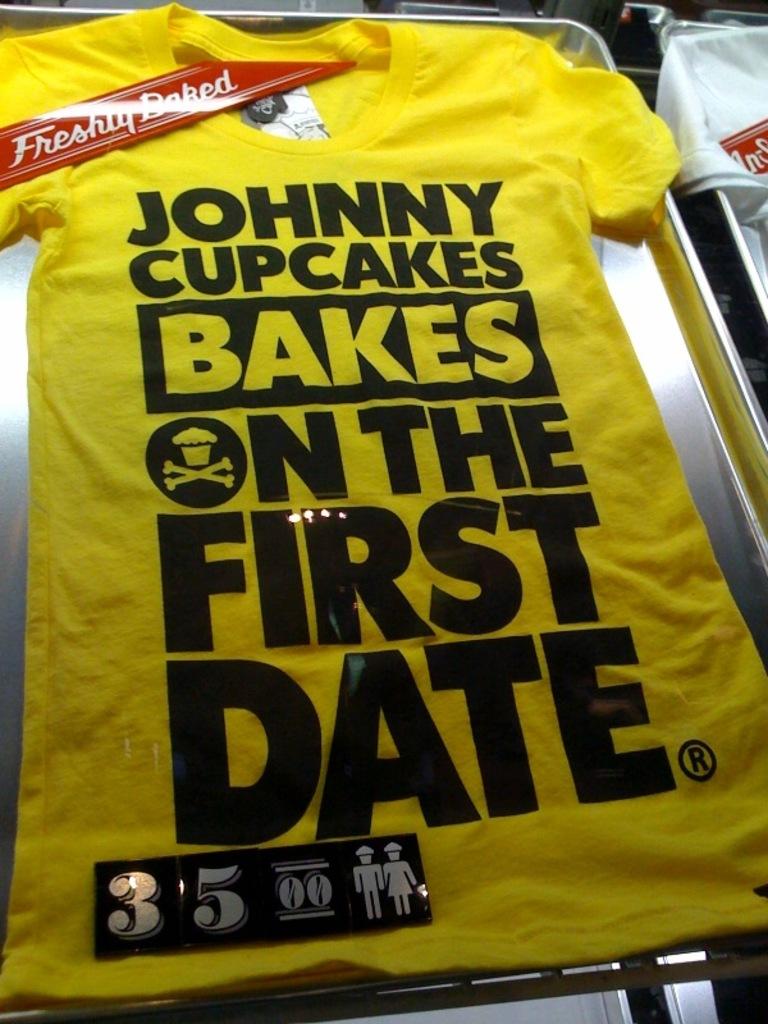What does johnny cupcakes do on the first date?
Offer a terse response. Bakes. 